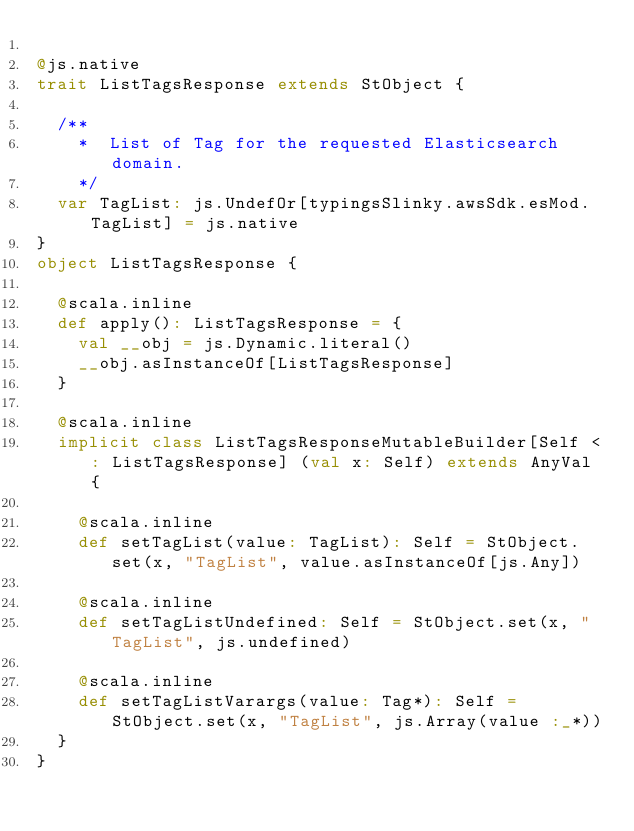<code> <loc_0><loc_0><loc_500><loc_500><_Scala_>
@js.native
trait ListTagsResponse extends StObject {
  
  /**
    *  List of Tag for the requested Elasticsearch domain.
    */
  var TagList: js.UndefOr[typingsSlinky.awsSdk.esMod.TagList] = js.native
}
object ListTagsResponse {
  
  @scala.inline
  def apply(): ListTagsResponse = {
    val __obj = js.Dynamic.literal()
    __obj.asInstanceOf[ListTagsResponse]
  }
  
  @scala.inline
  implicit class ListTagsResponseMutableBuilder[Self <: ListTagsResponse] (val x: Self) extends AnyVal {
    
    @scala.inline
    def setTagList(value: TagList): Self = StObject.set(x, "TagList", value.asInstanceOf[js.Any])
    
    @scala.inline
    def setTagListUndefined: Self = StObject.set(x, "TagList", js.undefined)
    
    @scala.inline
    def setTagListVarargs(value: Tag*): Self = StObject.set(x, "TagList", js.Array(value :_*))
  }
}
</code> 